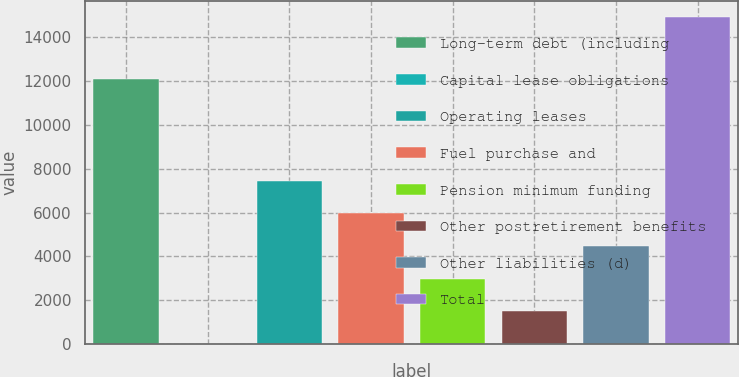<chart> <loc_0><loc_0><loc_500><loc_500><bar_chart><fcel>Long-term debt (including<fcel>Capital lease obligations<fcel>Operating leases<fcel>Fuel purchase and<fcel>Pension minimum funding<fcel>Other postretirement benefits<fcel>Other liabilities (d)<fcel>Total<nl><fcel>12108<fcel>2<fcel>7456.5<fcel>5965.6<fcel>2983.8<fcel>1492.9<fcel>4474.7<fcel>14911<nl></chart> 